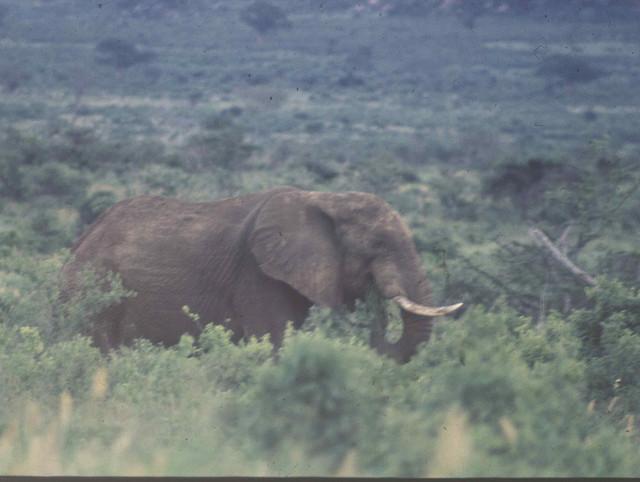Is there lots of vegetation for the elephant to eat?
Quick response, please. Yes. Is the elephant next to a glacier?
Quick response, please. No. What time of day is it?
Keep it brief. Noon. Is this a real photograph?
Concise answer only. Yes. What is the white pointy body part?
Write a very short answer. Tusk. 